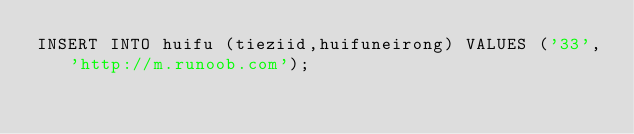<code> <loc_0><loc_0><loc_500><loc_500><_SQL_>INSERT INTO huifu (tieziid,huifuneirong) VALUES ('33','http://m.runoob.com');</code> 